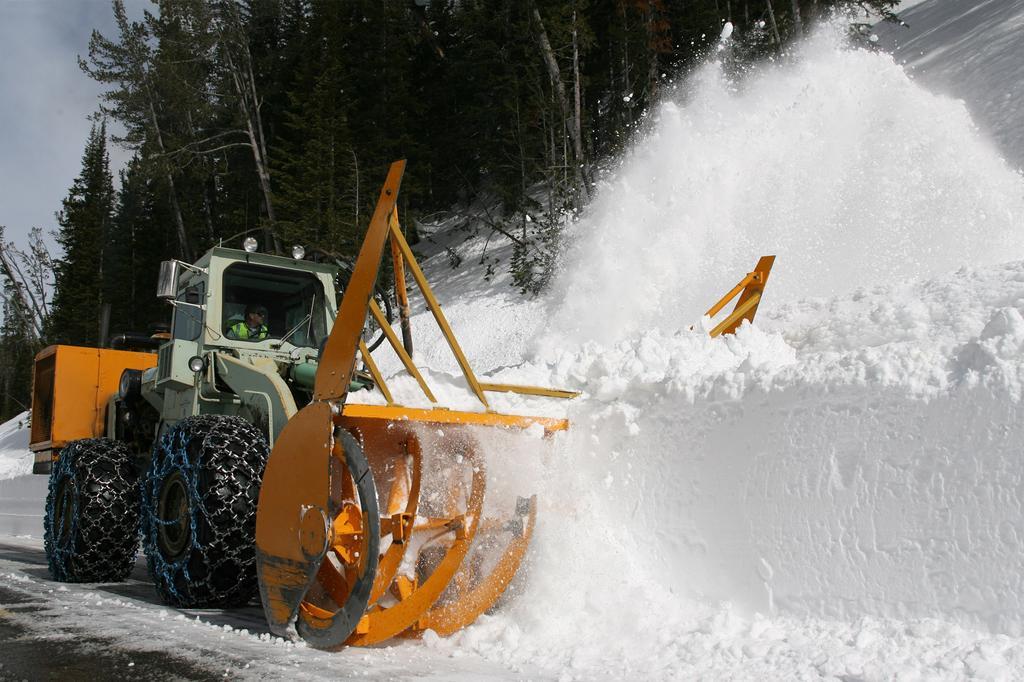In one or two sentences, can you explain what this image depicts? In the given image i can see a person in the crushing vehicle,snow,trees and in the background i can see the sky. 